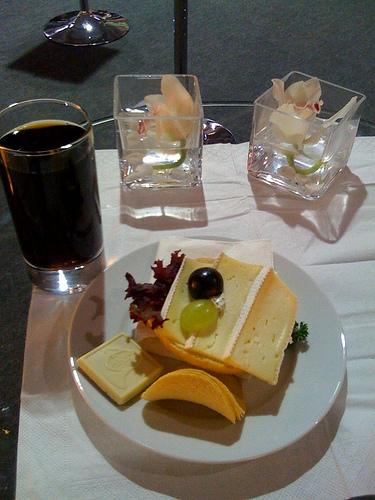How many different types of grapes can be seen on the image? There are two different types of grapes: one dark purple and one pale green. Evaluate the image regarding the arrangement and presentation of food. The image showcases a well-presented and visually appealing arrangement of food, with attention to detail and creativity in the serving of items. What is sitting on top of the sandwich? Cheese and two grapes, one red and one green, are sitting on top of the sandwich. How many Pringles chips are there on the plate? There are 5 Pringles chips on the plate. What is the main content inside the round glass? The round glass contains a dark beverage, possibly soda. Explain the details of the square glasses. The square glasses contain white orchids floating in them and there are two glasses in total. Describe the appearance of the white chocolate. The white chocolate is square-shaped and has a smooth, creamy texture. How would you describe the overall sentiment of the image? The overall sentiment of the image is inviting and appetizing, as it depicts a beautifully set table with a variety of delicious foods and visually appealing decorations. What color is the table top? The table top is grey. Can you list all the items that are detected on the dining table? White chocolate square, square glasses with white orchids, Pringles chips, grapes, sliced cheese, round glass with dark drink, ceramic plate with food, table decorations, soda, placemat, after dinner mint, and white napkin. 